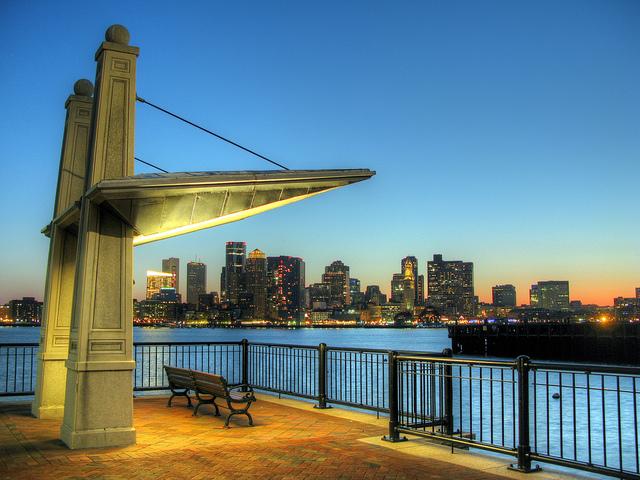Is this by a city?
Concise answer only. Yes. How many corners does the railing have?
Quick response, please. 3. How many benches are there?
Keep it brief. 1. 